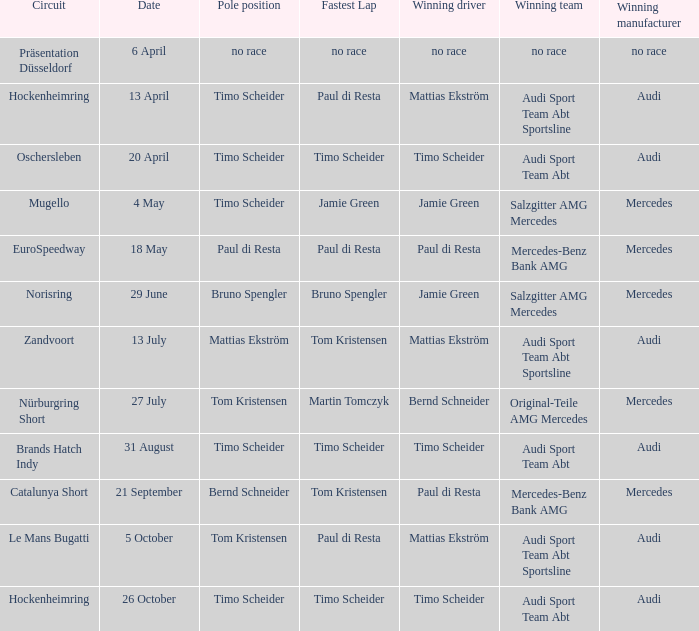Who is the winning driver of the Oschersleben circuit with Timo Scheider as the pole position? Timo Scheider. 